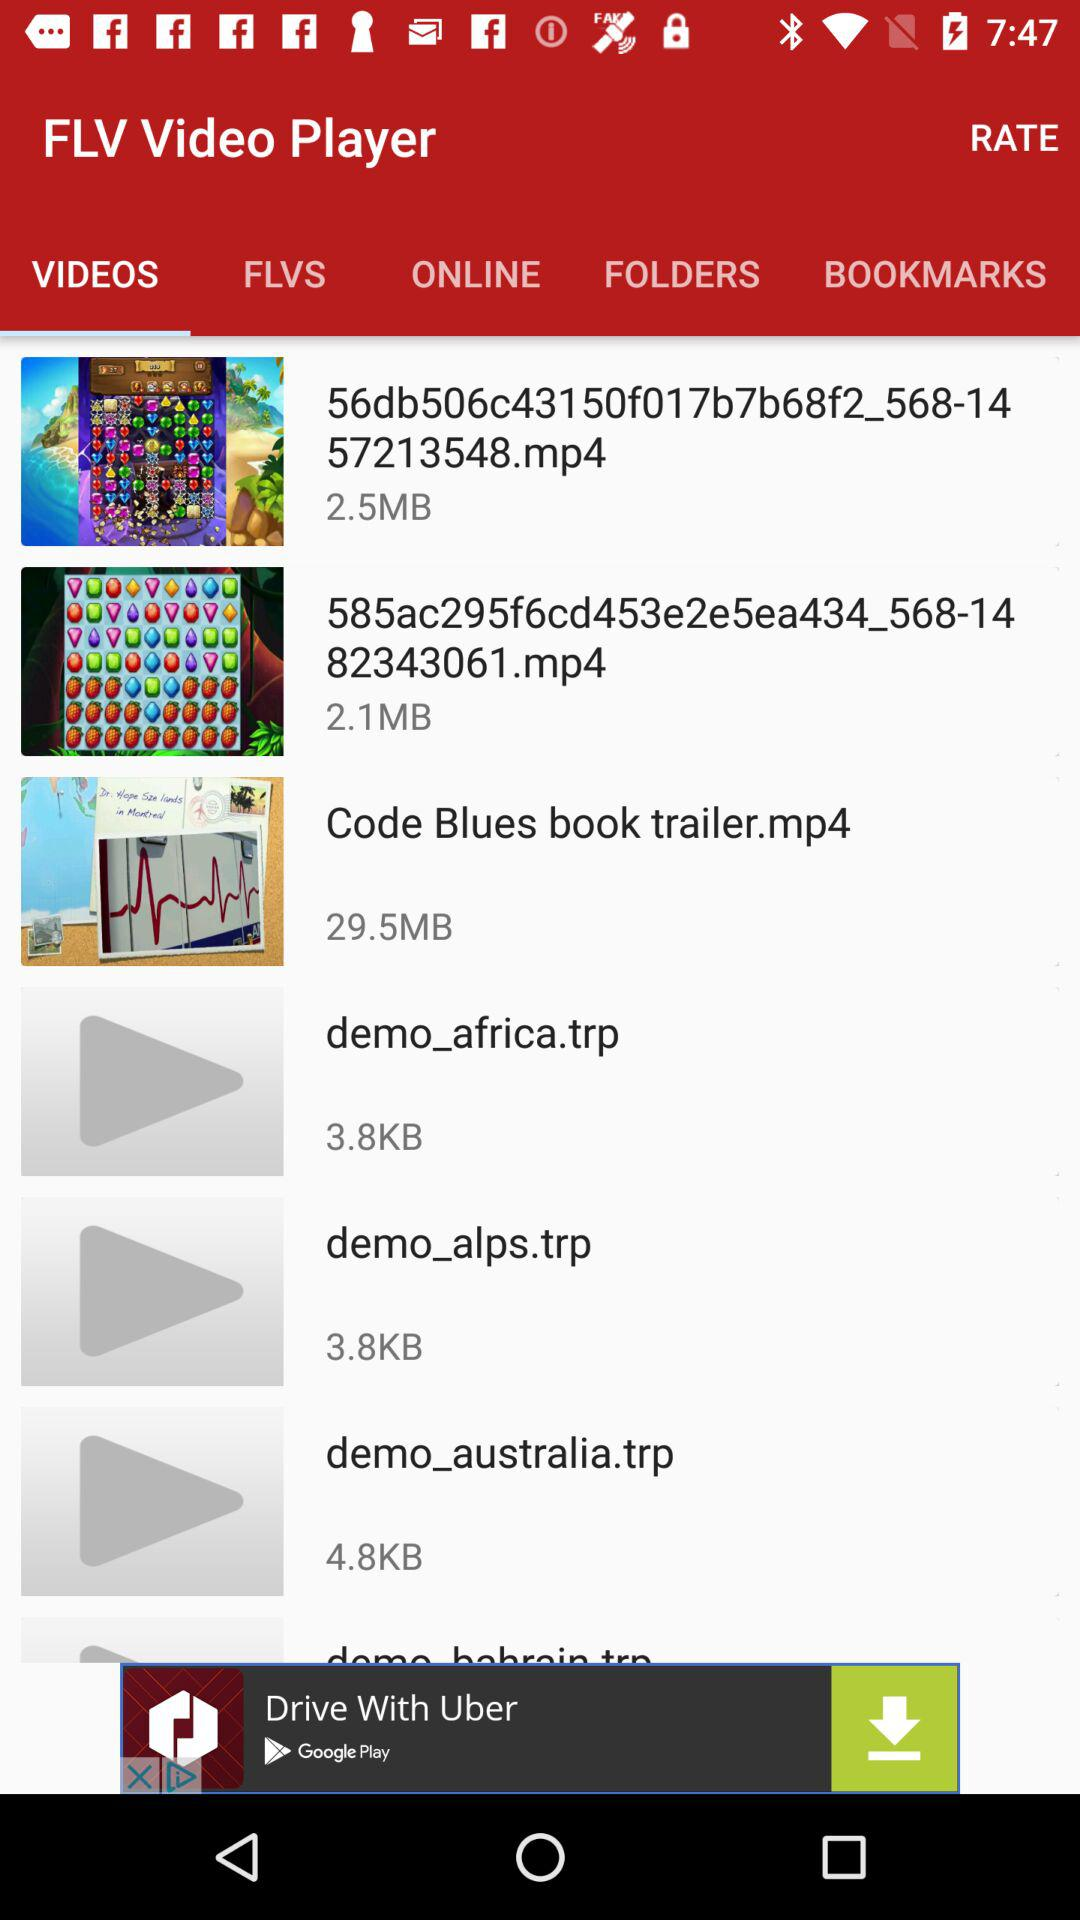What is the size of "demo_alps.trp"? The size is 3.8KB. 